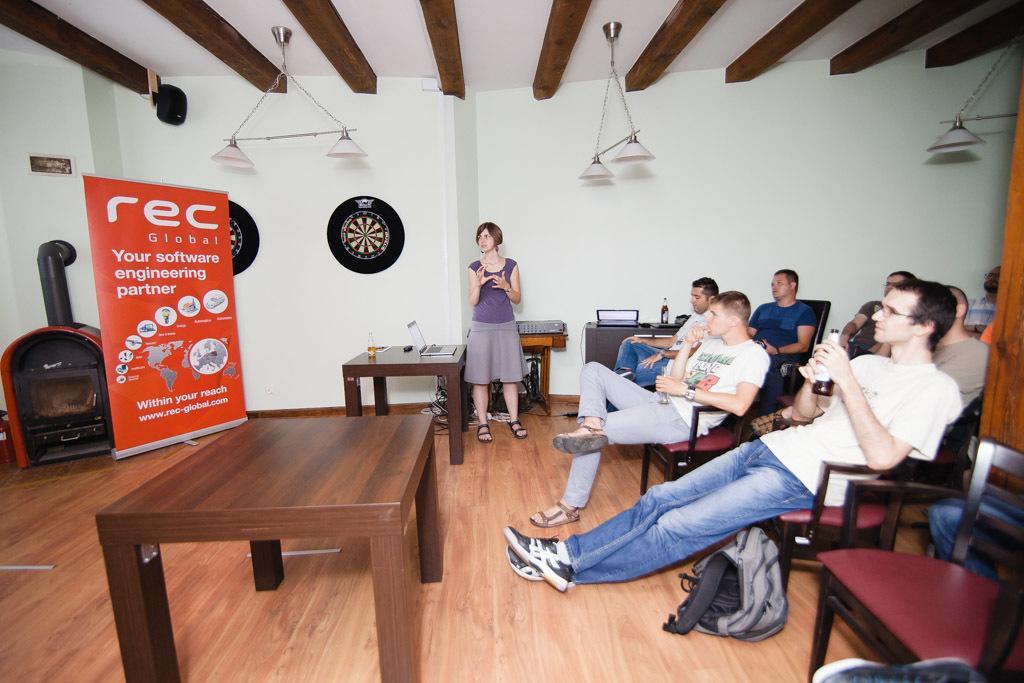Could you give a brief overview of what you see in this image? In this picture there are some people sitting here and there is a woman standing over here she has a laptop in front of her is also bottle kept on the table these people also have a beer bottle and their hands is a back it on the floor is also a table over here and in the background there is a banner,a oven and wall 